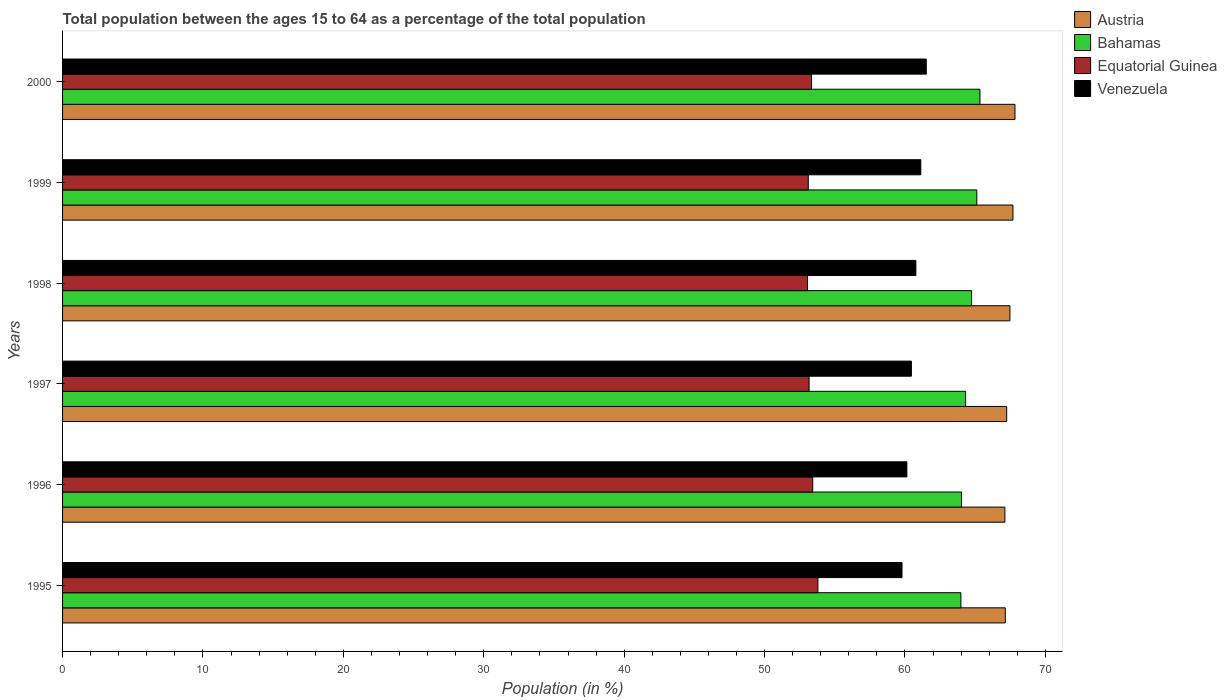How many different coloured bars are there?
Provide a succinct answer. 4. Are the number of bars per tick equal to the number of legend labels?
Offer a terse response. Yes. Are the number of bars on each tick of the Y-axis equal?
Offer a very short reply. Yes. What is the percentage of the population ages 15 to 64 in Bahamas in 1999?
Your answer should be very brief. 65.12. Across all years, what is the maximum percentage of the population ages 15 to 64 in Bahamas?
Your answer should be very brief. 65.34. Across all years, what is the minimum percentage of the population ages 15 to 64 in Bahamas?
Provide a succinct answer. 63.98. What is the total percentage of the population ages 15 to 64 in Equatorial Guinea in the graph?
Give a very brief answer. 319.92. What is the difference between the percentage of the population ages 15 to 64 in Bahamas in 1996 and that in 2000?
Ensure brevity in your answer.  -1.32. What is the difference between the percentage of the population ages 15 to 64 in Equatorial Guinea in 1996 and the percentage of the population ages 15 to 64 in Austria in 2000?
Give a very brief answer. -14.41. What is the average percentage of the population ages 15 to 64 in Equatorial Guinea per year?
Your answer should be very brief. 53.32. In the year 1998, what is the difference between the percentage of the population ages 15 to 64 in Venezuela and percentage of the population ages 15 to 64 in Equatorial Guinea?
Give a very brief answer. 7.72. In how many years, is the percentage of the population ages 15 to 64 in Equatorial Guinea greater than 38 ?
Your answer should be compact. 6. What is the ratio of the percentage of the population ages 15 to 64 in Bahamas in 1998 to that in 2000?
Provide a succinct answer. 0.99. Is the percentage of the population ages 15 to 64 in Bahamas in 1995 less than that in 1996?
Your response must be concise. Yes. Is the difference between the percentage of the population ages 15 to 64 in Venezuela in 1995 and 1996 greater than the difference between the percentage of the population ages 15 to 64 in Equatorial Guinea in 1995 and 1996?
Your answer should be very brief. No. What is the difference between the highest and the second highest percentage of the population ages 15 to 64 in Austria?
Your answer should be very brief. 0.14. What is the difference between the highest and the lowest percentage of the population ages 15 to 64 in Equatorial Guinea?
Keep it short and to the point. 0.75. What does the 4th bar from the top in 1999 represents?
Your response must be concise. Austria. What does the 4th bar from the bottom in 2000 represents?
Provide a short and direct response. Venezuela. How many bars are there?
Make the answer very short. 24. How many years are there in the graph?
Make the answer very short. 6. Does the graph contain any zero values?
Ensure brevity in your answer.  No. What is the title of the graph?
Your answer should be very brief. Total population between the ages 15 to 64 as a percentage of the total population. Does "Samoa" appear as one of the legend labels in the graph?
Make the answer very short. No. What is the label or title of the Y-axis?
Provide a succinct answer. Years. What is the Population (in %) of Austria in 1995?
Ensure brevity in your answer.  67.15. What is the Population (in %) in Bahamas in 1995?
Keep it short and to the point. 63.98. What is the Population (in %) in Equatorial Guinea in 1995?
Your answer should be compact. 53.8. What is the Population (in %) in Venezuela in 1995?
Provide a short and direct response. 59.79. What is the Population (in %) of Austria in 1996?
Offer a terse response. 67.12. What is the Population (in %) of Bahamas in 1996?
Give a very brief answer. 64.03. What is the Population (in %) in Equatorial Guinea in 1996?
Your answer should be very brief. 53.43. What is the Population (in %) of Venezuela in 1996?
Provide a succinct answer. 60.14. What is the Population (in %) in Austria in 1997?
Your response must be concise. 67.25. What is the Population (in %) in Bahamas in 1997?
Give a very brief answer. 64.32. What is the Population (in %) in Equatorial Guinea in 1997?
Make the answer very short. 53.17. What is the Population (in %) in Venezuela in 1997?
Provide a short and direct response. 60.46. What is the Population (in %) of Austria in 1998?
Offer a terse response. 67.47. What is the Population (in %) in Bahamas in 1998?
Provide a succinct answer. 64.75. What is the Population (in %) in Equatorial Guinea in 1998?
Offer a terse response. 53.06. What is the Population (in %) of Venezuela in 1998?
Keep it short and to the point. 60.78. What is the Population (in %) in Austria in 1999?
Ensure brevity in your answer.  67.69. What is the Population (in %) of Bahamas in 1999?
Give a very brief answer. 65.12. What is the Population (in %) in Equatorial Guinea in 1999?
Your answer should be very brief. 53.11. What is the Population (in %) in Venezuela in 1999?
Keep it short and to the point. 61.13. What is the Population (in %) of Austria in 2000?
Provide a succinct answer. 67.84. What is the Population (in %) in Bahamas in 2000?
Your answer should be compact. 65.34. What is the Population (in %) in Equatorial Guinea in 2000?
Your answer should be compact. 53.35. What is the Population (in %) in Venezuela in 2000?
Keep it short and to the point. 61.52. Across all years, what is the maximum Population (in %) in Austria?
Offer a terse response. 67.84. Across all years, what is the maximum Population (in %) in Bahamas?
Ensure brevity in your answer.  65.34. Across all years, what is the maximum Population (in %) of Equatorial Guinea?
Your answer should be compact. 53.8. Across all years, what is the maximum Population (in %) in Venezuela?
Offer a very short reply. 61.52. Across all years, what is the minimum Population (in %) of Austria?
Make the answer very short. 67.12. Across all years, what is the minimum Population (in %) of Bahamas?
Provide a succinct answer. 63.98. Across all years, what is the minimum Population (in %) of Equatorial Guinea?
Keep it short and to the point. 53.06. Across all years, what is the minimum Population (in %) of Venezuela?
Keep it short and to the point. 59.79. What is the total Population (in %) in Austria in the graph?
Your answer should be very brief. 404.51. What is the total Population (in %) in Bahamas in the graph?
Offer a very short reply. 387.54. What is the total Population (in %) of Equatorial Guinea in the graph?
Keep it short and to the point. 319.92. What is the total Population (in %) in Venezuela in the graph?
Offer a very short reply. 363.81. What is the difference between the Population (in %) in Austria in 1995 and that in 1996?
Give a very brief answer. 0.03. What is the difference between the Population (in %) in Bahamas in 1995 and that in 1996?
Your answer should be compact. -0.04. What is the difference between the Population (in %) of Equatorial Guinea in 1995 and that in 1996?
Offer a terse response. 0.37. What is the difference between the Population (in %) in Venezuela in 1995 and that in 1996?
Your answer should be very brief. -0.35. What is the difference between the Population (in %) of Austria in 1995 and that in 1997?
Provide a succinct answer. -0.1. What is the difference between the Population (in %) in Bahamas in 1995 and that in 1997?
Offer a very short reply. -0.34. What is the difference between the Population (in %) of Equatorial Guinea in 1995 and that in 1997?
Ensure brevity in your answer.  0.63. What is the difference between the Population (in %) of Venezuela in 1995 and that in 1997?
Make the answer very short. -0.67. What is the difference between the Population (in %) in Austria in 1995 and that in 1998?
Offer a very short reply. -0.33. What is the difference between the Population (in %) in Bahamas in 1995 and that in 1998?
Offer a very short reply. -0.76. What is the difference between the Population (in %) in Equatorial Guinea in 1995 and that in 1998?
Offer a terse response. 0.75. What is the difference between the Population (in %) of Venezuela in 1995 and that in 1998?
Your answer should be very brief. -0.99. What is the difference between the Population (in %) of Austria in 1995 and that in 1999?
Provide a short and direct response. -0.55. What is the difference between the Population (in %) in Bahamas in 1995 and that in 1999?
Your answer should be compact. -1.13. What is the difference between the Population (in %) in Equatorial Guinea in 1995 and that in 1999?
Provide a succinct answer. 0.69. What is the difference between the Population (in %) in Venezuela in 1995 and that in 1999?
Give a very brief answer. -1.34. What is the difference between the Population (in %) in Austria in 1995 and that in 2000?
Offer a terse response. -0.69. What is the difference between the Population (in %) in Bahamas in 1995 and that in 2000?
Your answer should be compact. -1.36. What is the difference between the Population (in %) in Equatorial Guinea in 1995 and that in 2000?
Make the answer very short. 0.45. What is the difference between the Population (in %) in Venezuela in 1995 and that in 2000?
Your answer should be compact. -1.73. What is the difference between the Population (in %) of Austria in 1996 and that in 1997?
Your answer should be compact. -0.13. What is the difference between the Population (in %) of Bahamas in 1996 and that in 1997?
Give a very brief answer. -0.29. What is the difference between the Population (in %) in Equatorial Guinea in 1996 and that in 1997?
Your answer should be very brief. 0.26. What is the difference between the Population (in %) of Venezuela in 1996 and that in 1997?
Keep it short and to the point. -0.32. What is the difference between the Population (in %) in Austria in 1996 and that in 1998?
Make the answer very short. -0.36. What is the difference between the Population (in %) of Bahamas in 1996 and that in 1998?
Provide a succinct answer. -0.72. What is the difference between the Population (in %) of Equatorial Guinea in 1996 and that in 1998?
Offer a terse response. 0.38. What is the difference between the Population (in %) in Venezuela in 1996 and that in 1998?
Keep it short and to the point. -0.64. What is the difference between the Population (in %) of Austria in 1996 and that in 1999?
Offer a very short reply. -0.58. What is the difference between the Population (in %) in Bahamas in 1996 and that in 1999?
Give a very brief answer. -1.09. What is the difference between the Population (in %) of Equatorial Guinea in 1996 and that in 1999?
Your answer should be very brief. 0.32. What is the difference between the Population (in %) of Venezuela in 1996 and that in 1999?
Offer a terse response. -0.99. What is the difference between the Population (in %) in Austria in 1996 and that in 2000?
Keep it short and to the point. -0.72. What is the difference between the Population (in %) of Bahamas in 1996 and that in 2000?
Keep it short and to the point. -1.32. What is the difference between the Population (in %) of Equatorial Guinea in 1996 and that in 2000?
Provide a succinct answer. 0.08. What is the difference between the Population (in %) in Venezuela in 1996 and that in 2000?
Provide a succinct answer. -1.38. What is the difference between the Population (in %) in Austria in 1997 and that in 1998?
Ensure brevity in your answer.  -0.23. What is the difference between the Population (in %) of Bahamas in 1997 and that in 1998?
Give a very brief answer. -0.43. What is the difference between the Population (in %) of Equatorial Guinea in 1997 and that in 1998?
Give a very brief answer. 0.12. What is the difference between the Population (in %) in Venezuela in 1997 and that in 1998?
Offer a very short reply. -0.32. What is the difference between the Population (in %) of Austria in 1997 and that in 1999?
Keep it short and to the point. -0.45. What is the difference between the Population (in %) in Bahamas in 1997 and that in 1999?
Provide a succinct answer. -0.8. What is the difference between the Population (in %) of Equatorial Guinea in 1997 and that in 1999?
Ensure brevity in your answer.  0.06. What is the difference between the Population (in %) in Venezuela in 1997 and that in 1999?
Your response must be concise. -0.67. What is the difference between the Population (in %) in Austria in 1997 and that in 2000?
Give a very brief answer. -0.59. What is the difference between the Population (in %) of Bahamas in 1997 and that in 2000?
Make the answer very short. -1.02. What is the difference between the Population (in %) in Equatorial Guinea in 1997 and that in 2000?
Give a very brief answer. -0.17. What is the difference between the Population (in %) of Venezuela in 1997 and that in 2000?
Your answer should be compact. -1.06. What is the difference between the Population (in %) in Austria in 1998 and that in 1999?
Make the answer very short. -0.22. What is the difference between the Population (in %) of Bahamas in 1998 and that in 1999?
Keep it short and to the point. -0.37. What is the difference between the Population (in %) of Equatorial Guinea in 1998 and that in 1999?
Provide a short and direct response. -0.06. What is the difference between the Population (in %) in Venezuela in 1998 and that in 1999?
Offer a very short reply. -0.35. What is the difference between the Population (in %) in Austria in 1998 and that in 2000?
Your answer should be very brief. -0.36. What is the difference between the Population (in %) of Bahamas in 1998 and that in 2000?
Keep it short and to the point. -0.6. What is the difference between the Population (in %) of Equatorial Guinea in 1998 and that in 2000?
Your answer should be very brief. -0.29. What is the difference between the Population (in %) of Venezuela in 1998 and that in 2000?
Your answer should be compact. -0.74. What is the difference between the Population (in %) of Austria in 1999 and that in 2000?
Offer a terse response. -0.14. What is the difference between the Population (in %) in Bahamas in 1999 and that in 2000?
Make the answer very short. -0.23. What is the difference between the Population (in %) of Equatorial Guinea in 1999 and that in 2000?
Provide a short and direct response. -0.23. What is the difference between the Population (in %) in Venezuela in 1999 and that in 2000?
Provide a short and direct response. -0.39. What is the difference between the Population (in %) in Austria in 1995 and the Population (in %) in Bahamas in 1996?
Your answer should be very brief. 3.12. What is the difference between the Population (in %) of Austria in 1995 and the Population (in %) of Equatorial Guinea in 1996?
Your response must be concise. 13.72. What is the difference between the Population (in %) of Austria in 1995 and the Population (in %) of Venezuela in 1996?
Your response must be concise. 7.01. What is the difference between the Population (in %) in Bahamas in 1995 and the Population (in %) in Equatorial Guinea in 1996?
Your answer should be compact. 10.55. What is the difference between the Population (in %) of Bahamas in 1995 and the Population (in %) of Venezuela in 1996?
Keep it short and to the point. 3.85. What is the difference between the Population (in %) in Equatorial Guinea in 1995 and the Population (in %) in Venezuela in 1996?
Give a very brief answer. -6.34. What is the difference between the Population (in %) in Austria in 1995 and the Population (in %) in Bahamas in 1997?
Your answer should be compact. 2.83. What is the difference between the Population (in %) of Austria in 1995 and the Population (in %) of Equatorial Guinea in 1997?
Provide a short and direct response. 13.97. What is the difference between the Population (in %) of Austria in 1995 and the Population (in %) of Venezuela in 1997?
Provide a short and direct response. 6.69. What is the difference between the Population (in %) of Bahamas in 1995 and the Population (in %) of Equatorial Guinea in 1997?
Offer a very short reply. 10.81. What is the difference between the Population (in %) of Bahamas in 1995 and the Population (in %) of Venezuela in 1997?
Provide a succinct answer. 3.52. What is the difference between the Population (in %) of Equatorial Guinea in 1995 and the Population (in %) of Venezuela in 1997?
Give a very brief answer. -6.66. What is the difference between the Population (in %) of Austria in 1995 and the Population (in %) of Equatorial Guinea in 1998?
Make the answer very short. 14.09. What is the difference between the Population (in %) of Austria in 1995 and the Population (in %) of Venezuela in 1998?
Provide a short and direct response. 6.37. What is the difference between the Population (in %) in Bahamas in 1995 and the Population (in %) in Equatorial Guinea in 1998?
Keep it short and to the point. 10.93. What is the difference between the Population (in %) of Bahamas in 1995 and the Population (in %) of Venezuela in 1998?
Keep it short and to the point. 3.21. What is the difference between the Population (in %) in Equatorial Guinea in 1995 and the Population (in %) in Venezuela in 1998?
Offer a very short reply. -6.98. What is the difference between the Population (in %) of Austria in 1995 and the Population (in %) of Bahamas in 1999?
Keep it short and to the point. 2.03. What is the difference between the Population (in %) of Austria in 1995 and the Population (in %) of Equatorial Guinea in 1999?
Offer a terse response. 14.03. What is the difference between the Population (in %) of Austria in 1995 and the Population (in %) of Venezuela in 1999?
Make the answer very short. 6.02. What is the difference between the Population (in %) in Bahamas in 1995 and the Population (in %) in Equatorial Guinea in 1999?
Give a very brief answer. 10.87. What is the difference between the Population (in %) in Bahamas in 1995 and the Population (in %) in Venezuela in 1999?
Offer a terse response. 2.85. What is the difference between the Population (in %) in Equatorial Guinea in 1995 and the Population (in %) in Venezuela in 1999?
Your answer should be compact. -7.33. What is the difference between the Population (in %) in Austria in 1995 and the Population (in %) in Bahamas in 2000?
Provide a succinct answer. 1.8. What is the difference between the Population (in %) in Austria in 1995 and the Population (in %) in Equatorial Guinea in 2000?
Ensure brevity in your answer.  13.8. What is the difference between the Population (in %) in Austria in 1995 and the Population (in %) in Venezuela in 2000?
Your answer should be very brief. 5.63. What is the difference between the Population (in %) in Bahamas in 1995 and the Population (in %) in Equatorial Guinea in 2000?
Your response must be concise. 10.64. What is the difference between the Population (in %) of Bahamas in 1995 and the Population (in %) of Venezuela in 2000?
Ensure brevity in your answer.  2.46. What is the difference between the Population (in %) of Equatorial Guinea in 1995 and the Population (in %) of Venezuela in 2000?
Ensure brevity in your answer.  -7.72. What is the difference between the Population (in %) in Austria in 1996 and the Population (in %) in Bahamas in 1997?
Give a very brief answer. 2.8. What is the difference between the Population (in %) in Austria in 1996 and the Population (in %) in Equatorial Guinea in 1997?
Your answer should be compact. 13.95. What is the difference between the Population (in %) of Austria in 1996 and the Population (in %) of Venezuela in 1997?
Make the answer very short. 6.66. What is the difference between the Population (in %) in Bahamas in 1996 and the Population (in %) in Equatorial Guinea in 1997?
Offer a terse response. 10.86. What is the difference between the Population (in %) in Bahamas in 1996 and the Population (in %) in Venezuela in 1997?
Keep it short and to the point. 3.57. What is the difference between the Population (in %) in Equatorial Guinea in 1996 and the Population (in %) in Venezuela in 1997?
Offer a very short reply. -7.03. What is the difference between the Population (in %) in Austria in 1996 and the Population (in %) in Bahamas in 1998?
Offer a very short reply. 2.37. What is the difference between the Population (in %) of Austria in 1996 and the Population (in %) of Equatorial Guinea in 1998?
Your answer should be compact. 14.06. What is the difference between the Population (in %) of Austria in 1996 and the Population (in %) of Venezuela in 1998?
Provide a succinct answer. 6.34. What is the difference between the Population (in %) of Bahamas in 1996 and the Population (in %) of Equatorial Guinea in 1998?
Offer a very short reply. 10.97. What is the difference between the Population (in %) in Bahamas in 1996 and the Population (in %) in Venezuela in 1998?
Offer a very short reply. 3.25. What is the difference between the Population (in %) of Equatorial Guinea in 1996 and the Population (in %) of Venezuela in 1998?
Provide a succinct answer. -7.35. What is the difference between the Population (in %) in Austria in 1996 and the Population (in %) in Bahamas in 1999?
Give a very brief answer. 2. What is the difference between the Population (in %) in Austria in 1996 and the Population (in %) in Equatorial Guinea in 1999?
Ensure brevity in your answer.  14. What is the difference between the Population (in %) of Austria in 1996 and the Population (in %) of Venezuela in 1999?
Ensure brevity in your answer.  5.99. What is the difference between the Population (in %) in Bahamas in 1996 and the Population (in %) in Equatorial Guinea in 1999?
Give a very brief answer. 10.91. What is the difference between the Population (in %) of Bahamas in 1996 and the Population (in %) of Venezuela in 1999?
Offer a terse response. 2.9. What is the difference between the Population (in %) of Equatorial Guinea in 1996 and the Population (in %) of Venezuela in 1999?
Ensure brevity in your answer.  -7.7. What is the difference between the Population (in %) of Austria in 1996 and the Population (in %) of Bahamas in 2000?
Provide a succinct answer. 1.77. What is the difference between the Population (in %) of Austria in 1996 and the Population (in %) of Equatorial Guinea in 2000?
Your answer should be compact. 13.77. What is the difference between the Population (in %) of Austria in 1996 and the Population (in %) of Venezuela in 2000?
Provide a short and direct response. 5.6. What is the difference between the Population (in %) of Bahamas in 1996 and the Population (in %) of Equatorial Guinea in 2000?
Ensure brevity in your answer.  10.68. What is the difference between the Population (in %) in Bahamas in 1996 and the Population (in %) in Venezuela in 2000?
Your answer should be compact. 2.51. What is the difference between the Population (in %) in Equatorial Guinea in 1996 and the Population (in %) in Venezuela in 2000?
Provide a short and direct response. -8.09. What is the difference between the Population (in %) of Austria in 1997 and the Population (in %) of Bahamas in 1998?
Ensure brevity in your answer.  2.5. What is the difference between the Population (in %) in Austria in 1997 and the Population (in %) in Equatorial Guinea in 1998?
Your answer should be compact. 14.19. What is the difference between the Population (in %) in Austria in 1997 and the Population (in %) in Venezuela in 1998?
Keep it short and to the point. 6.47. What is the difference between the Population (in %) of Bahamas in 1997 and the Population (in %) of Equatorial Guinea in 1998?
Provide a succinct answer. 11.26. What is the difference between the Population (in %) of Bahamas in 1997 and the Population (in %) of Venezuela in 1998?
Provide a short and direct response. 3.54. What is the difference between the Population (in %) of Equatorial Guinea in 1997 and the Population (in %) of Venezuela in 1998?
Offer a terse response. -7.61. What is the difference between the Population (in %) of Austria in 1997 and the Population (in %) of Bahamas in 1999?
Your answer should be very brief. 2.13. What is the difference between the Population (in %) of Austria in 1997 and the Population (in %) of Equatorial Guinea in 1999?
Keep it short and to the point. 14.13. What is the difference between the Population (in %) in Austria in 1997 and the Population (in %) in Venezuela in 1999?
Ensure brevity in your answer.  6.12. What is the difference between the Population (in %) in Bahamas in 1997 and the Population (in %) in Equatorial Guinea in 1999?
Make the answer very short. 11.21. What is the difference between the Population (in %) in Bahamas in 1997 and the Population (in %) in Venezuela in 1999?
Your answer should be compact. 3.19. What is the difference between the Population (in %) in Equatorial Guinea in 1997 and the Population (in %) in Venezuela in 1999?
Your response must be concise. -7.96. What is the difference between the Population (in %) in Austria in 1997 and the Population (in %) in Bahamas in 2000?
Provide a succinct answer. 1.9. What is the difference between the Population (in %) in Austria in 1997 and the Population (in %) in Equatorial Guinea in 2000?
Offer a terse response. 13.9. What is the difference between the Population (in %) in Austria in 1997 and the Population (in %) in Venezuela in 2000?
Offer a terse response. 5.73. What is the difference between the Population (in %) in Bahamas in 1997 and the Population (in %) in Equatorial Guinea in 2000?
Your response must be concise. 10.97. What is the difference between the Population (in %) of Bahamas in 1997 and the Population (in %) of Venezuela in 2000?
Offer a very short reply. 2.8. What is the difference between the Population (in %) in Equatorial Guinea in 1997 and the Population (in %) in Venezuela in 2000?
Offer a terse response. -8.35. What is the difference between the Population (in %) of Austria in 1998 and the Population (in %) of Bahamas in 1999?
Make the answer very short. 2.36. What is the difference between the Population (in %) of Austria in 1998 and the Population (in %) of Equatorial Guinea in 1999?
Offer a terse response. 14.36. What is the difference between the Population (in %) in Austria in 1998 and the Population (in %) in Venezuela in 1999?
Your response must be concise. 6.35. What is the difference between the Population (in %) of Bahamas in 1998 and the Population (in %) of Equatorial Guinea in 1999?
Give a very brief answer. 11.63. What is the difference between the Population (in %) of Bahamas in 1998 and the Population (in %) of Venezuela in 1999?
Provide a succinct answer. 3.62. What is the difference between the Population (in %) of Equatorial Guinea in 1998 and the Population (in %) of Venezuela in 1999?
Ensure brevity in your answer.  -8.07. What is the difference between the Population (in %) in Austria in 1998 and the Population (in %) in Bahamas in 2000?
Provide a short and direct response. 2.13. What is the difference between the Population (in %) in Austria in 1998 and the Population (in %) in Equatorial Guinea in 2000?
Your answer should be very brief. 14.13. What is the difference between the Population (in %) in Austria in 1998 and the Population (in %) in Venezuela in 2000?
Make the answer very short. 5.96. What is the difference between the Population (in %) in Bahamas in 1998 and the Population (in %) in Equatorial Guinea in 2000?
Ensure brevity in your answer.  11.4. What is the difference between the Population (in %) in Bahamas in 1998 and the Population (in %) in Venezuela in 2000?
Ensure brevity in your answer.  3.23. What is the difference between the Population (in %) in Equatorial Guinea in 1998 and the Population (in %) in Venezuela in 2000?
Give a very brief answer. -8.46. What is the difference between the Population (in %) of Austria in 1999 and the Population (in %) of Bahamas in 2000?
Your response must be concise. 2.35. What is the difference between the Population (in %) of Austria in 1999 and the Population (in %) of Equatorial Guinea in 2000?
Give a very brief answer. 14.35. What is the difference between the Population (in %) in Austria in 1999 and the Population (in %) in Venezuela in 2000?
Your answer should be compact. 6.17. What is the difference between the Population (in %) in Bahamas in 1999 and the Population (in %) in Equatorial Guinea in 2000?
Provide a succinct answer. 11.77. What is the difference between the Population (in %) of Bahamas in 1999 and the Population (in %) of Venezuela in 2000?
Your answer should be very brief. 3.6. What is the difference between the Population (in %) of Equatorial Guinea in 1999 and the Population (in %) of Venezuela in 2000?
Your answer should be compact. -8.4. What is the average Population (in %) in Austria per year?
Your response must be concise. 67.42. What is the average Population (in %) in Bahamas per year?
Provide a short and direct response. 64.59. What is the average Population (in %) in Equatorial Guinea per year?
Provide a short and direct response. 53.32. What is the average Population (in %) in Venezuela per year?
Give a very brief answer. 60.64. In the year 1995, what is the difference between the Population (in %) of Austria and Population (in %) of Bahamas?
Make the answer very short. 3.16. In the year 1995, what is the difference between the Population (in %) in Austria and Population (in %) in Equatorial Guinea?
Offer a terse response. 13.35. In the year 1995, what is the difference between the Population (in %) in Austria and Population (in %) in Venezuela?
Your response must be concise. 7.36. In the year 1995, what is the difference between the Population (in %) in Bahamas and Population (in %) in Equatorial Guinea?
Give a very brief answer. 10.18. In the year 1995, what is the difference between the Population (in %) in Bahamas and Population (in %) in Venezuela?
Keep it short and to the point. 4.19. In the year 1995, what is the difference between the Population (in %) of Equatorial Guinea and Population (in %) of Venezuela?
Ensure brevity in your answer.  -5.99. In the year 1996, what is the difference between the Population (in %) of Austria and Population (in %) of Bahamas?
Ensure brevity in your answer.  3.09. In the year 1996, what is the difference between the Population (in %) in Austria and Population (in %) in Equatorial Guinea?
Make the answer very short. 13.69. In the year 1996, what is the difference between the Population (in %) of Austria and Population (in %) of Venezuela?
Provide a short and direct response. 6.98. In the year 1996, what is the difference between the Population (in %) in Bahamas and Population (in %) in Equatorial Guinea?
Offer a terse response. 10.6. In the year 1996, what is the difference between the Population (in %) in Bahamas and Population (in %) in Venezuela?
Your response must be concise. 3.89. In the year 1996, what is the difference between the Population (in %) of Equatorial Guinea and Population (in %) of Venezuela?
Provide a short and direct response. -6.71. In the year 1997, what is the difference between the Population (in %) of Austria and Population (in %) of Bahamas?
Your answer should be compact. 2.93. In the year 1997, what is the difference between the Population (in %) of Austria and Population (in %) of Equatorial Guinea?
Keep it short and to the point. 14.07. In the year 1997, what is the difference between the Population (in %) of Austria and Population (in %) of Venezuela?
Offer a very short reply. 6.79. In the year 1997, what is the difference between the Population (in %) of Bahamas and Population (in %) of Equatorial Guinea?
Your answer should be very brief. 11.15. In the year 1997, what is the difference between the Population (in %) of Bahamas and Population (in %) of Venezuela?
Make the answer very short. 3.86. In the year 1997, what is the difference between the Population (in %) of Equatorial Guinea and Population (in %) of Venezuela?
Your answer should be very brief. -7.29. In the year 1998, what is the difference between the Population (in %) of Austria and Population (in %) of Bahamas?
Offer a terse response. 2.73. In the year 1998, what is the difference between the Population (in %) in Austria and Population (in %) in Equatorial Guinea?
Offer a very short reply. 14.42. In the year 1998, what is the difference between the Population (in %) of Austria and Population (in %) of Venezuela?
Your response must be concise. 6.7. In the year 1998, what is the difference between the Population (in %) in Bahamas and Population (in %) in Equatorial Guinea?
Ensure brevity in your answer.  11.69. In the year 1998, what is the difference between the Population (in %) of Bahamas and Population (in %) of Venezuela?
Offer a very short reply. 3.97. In the year 1998, what is the difference between the Population (in %) of Equatorial Guinea and Population (in %) of Venezuela?
Offer a very short reply. -7.72. In the year 1999, what is the difference between the Population (in %) in Austria and Population (in %) in Bahamas?
Ensure brevity in your answer.  2.58. In the year 1999, what is the difference between the Population (in %) in Austria and Population (in %) in Equatorial Guinea?
Provide a succinct answer. 14.58. In the year 1999, what is the difference between the Population (in %) of Austria and Population (in %) of Venezuela?
Your answer should be very brief. 6.56. In the year 1999, what is the difference between the Population (in %) in Bahamas and Population (in %) in Equatorial Guinea?
Your answer should be very brief. 12. In the year 1999, what is the difference between the Population (in %) of Bahamas and Population (in %) of Venezuela?
Make the answer very short. 3.99. In the year 1999, what is the difference between the Population (in %) in Equatorial Guinea and Population (in %) in Venezuela?
Offer a terse response. -8.01. In the year 2000, what is the difference between the Population (in %) in Austria and Population (in %) in Bahamas?
Your answer should be compact. 2.49. In the year 2000, what is the difference between the Population (in %) of Austria and Population (in %) of Equatorial Guinea?
Give a very brief answer. 14.49. In the year 2000, what is the difference between the Population (in %) in Austria and Population (in %) in Venezuela?
Offer a terse response. 6.32. In the year 2000, what is the difference between the Population (in %) of Bahamas and Population (in %) of Equatorial Guinea?
Offer a very short reply. 12. In the year 2000, what is the difference between the Population (in %) in Bahamas and Population (in %) in Venezuela?
Provide a short and direct response. 3.82. In the year 2000, what is the difference between the Population (in %) of Equatorial Guinea and Population (in %) of Venezuela?
Offer a terse response. -8.17. What is the ratio of the Population (in %) of Austria in 1995 to that in 1996?
Your answer should be very brief. 1. What is the ratio of the Population (in %) in Bahamas in 1995 to that in 1996?
Your response must be concise. 1. What is the ratio of the Population (in %) in Austria in 1995 to that in 1997?
Offer a very short reply. 1. What is the ratio of the Population (in %) in Bahamas in 1995 to that in 1997?
Your response must be concise. 0.99. What is the ratio of the Population (in %) of Equatorial Guinea in 1995 to that in 1997?
Ensure brevity in your answer.  1.01. What is the ratio of the Population (in %) in Venezuela in 1995 to that in 1997?
Provide a short and direct response. 0.99. What is the ratio of the Population (in %) of Austria in 1995 to that in 1998?
Make the answer very short. 1. What is the ratio of the Population (in %) in Equatorial Guinea in 1995 to that in 1998?
Your answer should be compact. 1.01. What is the ratio of the Population (in %) in Venezuela in 1995 to that in 1998?
Make the answer very short. 0.98. What is the ratio of the Population (in %) in Bahamas in 1995 to that in 1999?
Provide a short and direct response. 0.98. What is the ratio of the Population (in %) of Equatorial Guinea in 1995 to that in 1999?
Offer a terse response. 1.01. What is the ratio of the Population (in %) of Venezuela in 1995 to that in 1999?
Your answer should be very brief. 0.98. What is the ratio of the Population (in %) of Bahamas in 1995 to that in 2000?
Your answer should be compact. 0.98. What is the ratio of the Population (in %) of Equatorial Guinea in 1995 to that in 2000?
Make the answer very short. 1.01. What is the ratio of the Population (in %) in Venezuela in 1995 to that in 2000?
Offer a very short reply. 0.97. What is the ratio of the Population (in %) in Austria in 1996 to that in 1997?
Provide a succinct answer. 1. What is the ratio of the Population (in %) in Bahamas in 1996 to that in 1997?
Offer a very short reply. 1. What is the ratio of the Population (in %) of Bahamas in 1996 to that in 1998?
Offer a terse response. 0.99. What is the ratio of the Population (in %) in Equatorial Guinea in 1996 to that in 1998?
Give a very brief answer. 1.01. What is the ratio of the Population (in %) of Venezuela in 1996 to that in 1998?
Provide a short and direct response. 0.99. What is the ratio of the Population (in %) in Austria in 1996 to that in 1999?
Your answer should be very brief. 0.99. What is the ratio of the Population (in %) in Bahamas in 1996 to that in 1999?
Offer a very short reply. 0.98. What is the ratio of the Population (in %) of Venezuela in 1996 to that in 1999?
Make the answer very short. 0.98. What is the ratio of the Population (in %) in Austria in 1996 to that in 2000?
Your response must be concise. 0.99. What is the ratio of the Population (in %) of Bahamas in 1996 to that in 2000?
Make the answer very short. 0.98. What is the ratio of the Population (in %) in Venezuela in 1996 to that in 2000?
Offer a terse response. 0.98. What is the ratio of the Population (in %) of Austria in 1997 to that in 1998?
Make the answer very short. 1. What is the ratio of the Population (in %) of Equatorial Guinea in 1997 to that in 1998?
Your answer should be compact. 1. What is the ratio of the Population (in %) in Austria in 1997 to that in 1999?
Offer a terse response. 0.99. What is the ratio of the Population (in %) in Equatorial Guinea in 1997 to that in 1999?
Ensure brevity in your answer.  1. What is the ratio of the Population (in %) in Austria in 1997 to that in 2000?
Provide a succinct answer. 0.99. What is the ratio of the Population (in %) of Bahamas in 1997 to that in 2000?
Your response must be concise. 0.98. What is the ratio of the Population (in %) of Equatorial Guinea in 1997 to that in 2000?
Make the answer very short. 1. What is the ratio of the Population (in %) in Venezuela in 1997 to that in 2000?
Offer a terse response. 0.98. What is the ratio of the Population (in %) in Austria in 1998 to that in 1999?
Offer a very short reply. 1. What is the ratio of the Population (in %) of Bahamas in 1998 to that in 1999?
Your response must be concise. 0.99. What is the ratio of the Population (in %) of Equatorial Guinea in 1998 to that in 1999?
Your answer should be compact. 1. What is the ratio of the Population (in %) of Austria in 1998 to that in 2000?
Your response must be concise. 0.99. What is the ratio of the Population (in %) of Bahamas in 1998 to that in 2000?
Ensure brevity in your answer.  0.99. What is the ratio of the Population (in %) in Equatorial Guinea in 1998 to that in 2000?
Ensure brevity in your answer.  0.99. What is the ratio of the Population (in %) in Austria in 1999 to that in 2000?
Give a very brief answer. 1. What is the ratio of the Population (in %) in Equatorial Guinea in 1999 to that in 2000?
Make the answer very short. 1. What is the ratio of the Population (in %) of Venezuela in 1999 to that in 2000?
Provide a short and direct response. 0.99. What is the difference between the highest and the second highest Population (in %) in Austria?
Ensure brevity in your answer.  0.14. What is the difference between the highest and the second highest Population (in %) of Bahamas?
Ensure brevity in your answer.  0.23. What is the difference between the highest and the second highest Population (in %) of Equatorial Guinea?
Provide a short and direct response. 0.37. What is the difference between the highest and the second highest Population (in %) in Venezuela?
Your answer should be very brief. 0.39. What is the difference between the highest and the lowest Population (in %) in Austria?
Provide a short and direct response. 0.72. What is the difference between the highest and the lowest Population (in %) of Bahamas?
Give a very brief answer. 1.36. What is the difference between the highest and the lowest Population (in %) in Equatorial Guinea?
Provide a short and direct response. 0.75. What is the difference between the highest and the lowest Population (in %) in Venezuela?
Your response must be concise. 1.73. 